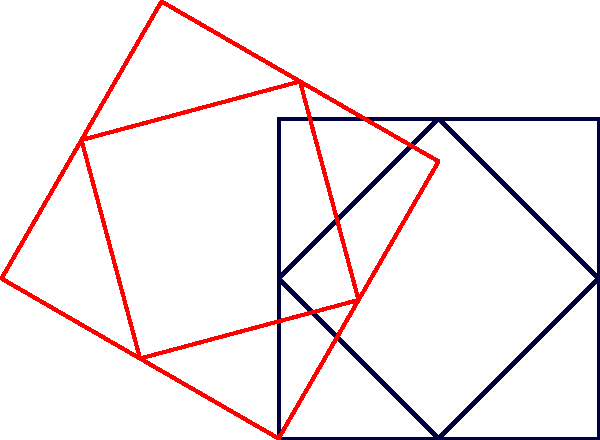A traditional Estonian geometric pattern, inspired by Baltic folk art, is shown in dark blue. The pattern is rotated 60° counterclockwise around point O. What is the measure of the smallest angle formed between any line segment of the original pattern and its corresponding rotated line segment (shown in red)? To find the smallest angle between the original and rotated pattern, we can follow these steps:

1. Recognize that the pattern consists of a square and a diamond shape.
2. The rotation angle is given as 60° counterclockwise around point O.
3. In a rotation, all line segments are rotated by the same angle.
4. The angle between an original line segment and its rotated counterpart will always be equal to the rotation angle.
5. Therefore, the smallest angle formed between any line segment of the original pattern and its corresponding rotated line segment is 60°.

This angle is consistent for all corresponding line segments, as rotation preserves angles and distances from the center of rotation.
Answer: 60° 